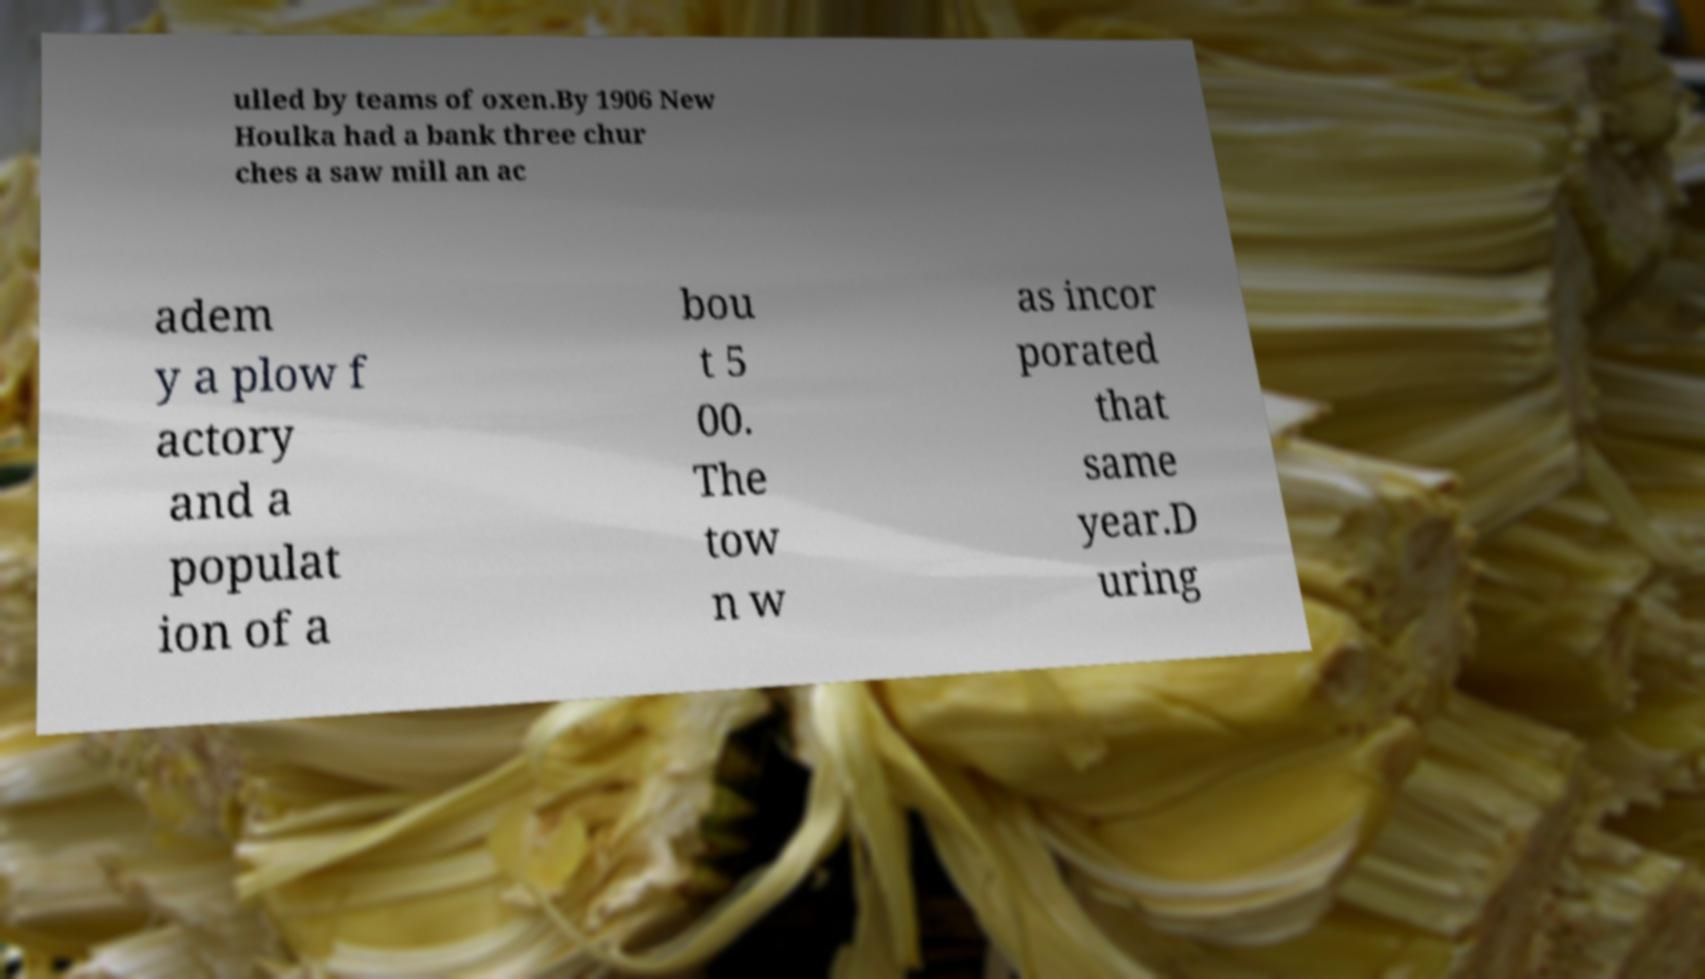I need the written content from this picture converted into text. Can you do that? ulled by teams of oxen.By 1906 New Houlka had a bank three chur ches a saw mill an ac adem y a plow f actory and a populat ion of a bou t 5 00. The tow n w as incor porated that same year.D uring 